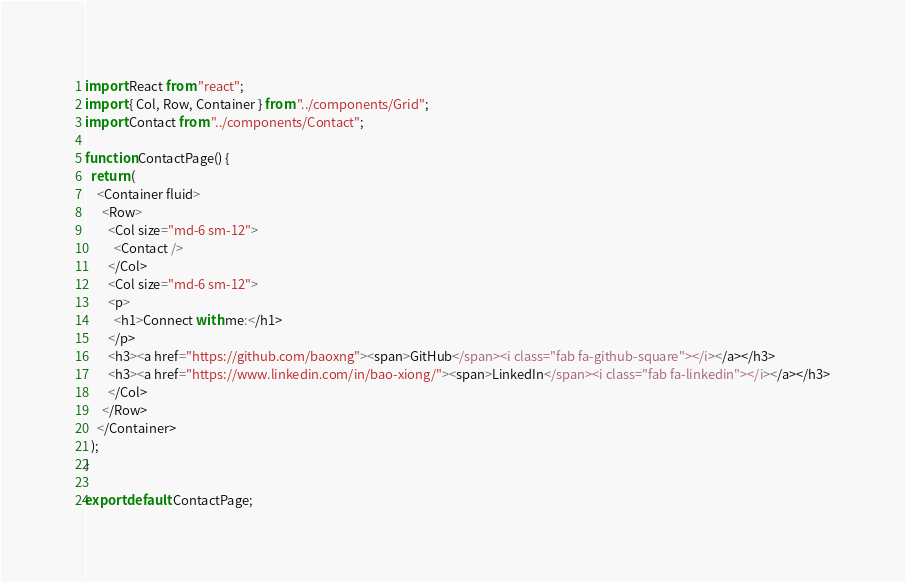<code> <loc_0><loc_0><loc_500><loc_500><_JavaScript_>import React from "react";
import { Col, Row, Container } from "../components/Grid";
import Contact from "../components/Contact";

function ContactPage() {
  return (
    <Container fluid>
      <Row>
        <Col size="md-6 sm-12">
          <Contact />
        </Col>
        <Col size="md-6 sm-12">
        <p>
          <h1>Connect with me:</h1>
        </p>
        <h3><a href="https://github.com/baoxng"><span>GitHub</span><i class="fab fa-github-square"></i></a></h3>
        <h3><a href="https://www.linkedin.com/in/bao-xiong/"><span>LinkedIn</span><i class="fab fa-linkedin"></i></a></h3>
        </Col>
      </Row>
    </Container>
  );
}

export default ContactPage;</code> 